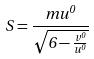Convert formula to latex. <formula><loc_0><loc_0><loc_500><loc_500>S = \frac { m u ^ { 0 } } { \sqrt { 6 - \frac { v ^ { 0 } } { u ^ { 0 } } } }</formula> 